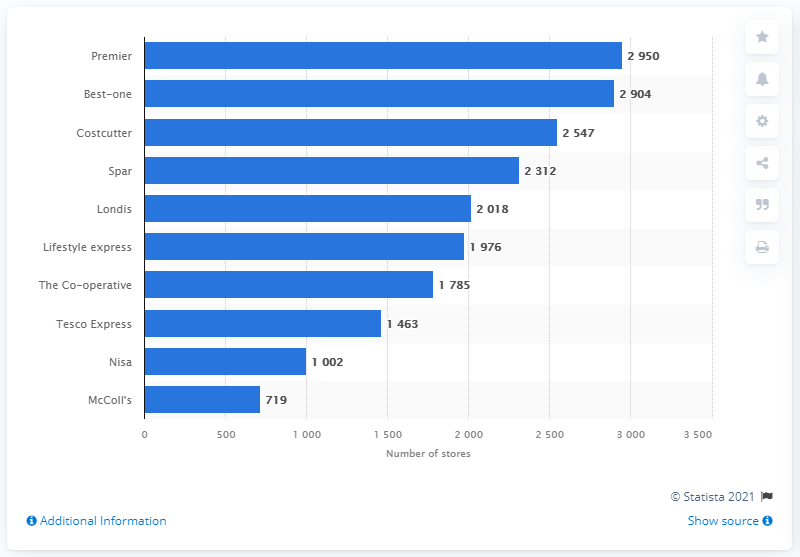Draw attention to some important aspects in this diagram. In 2014, the group with the highest number of convenience stores in the UK was Premier. In 2014, Premier had a total of 2950 convenience stores. 